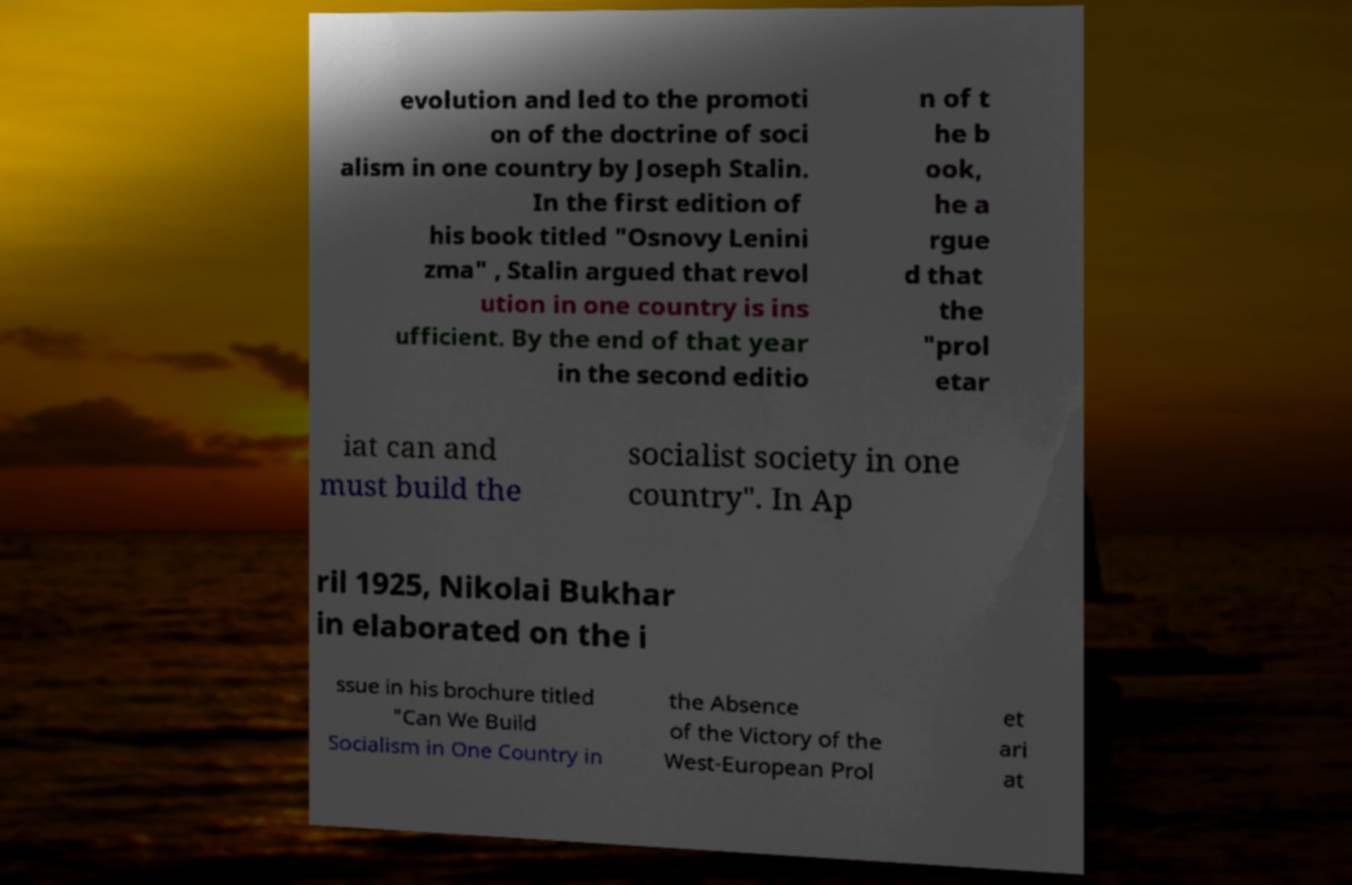Can you accurately transcribe the text from the provided image for me? evolution and led to the promoti on of the doctrine of soci alism in one country by Joseph Stalin. In the first edition of his book titled "Osnovy Lenini zma" , Stalin argued that revol ution in one country is ins ufficient. By the end of that year in the second editio n of t he b ook, he a rgue d that the "prol etar iat can and must build the socialist society in one country". In Ap ril 1925, Nikolai Bukhar in elaborated on the i ssue in his brochure titled "Can We Build Socialism in One Country in the Absence of the Victory of the West-European Prol et ari at 